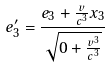<formula> <loc_0><loc_0><loc_500><loc_500>e _ { 3 } ^ { \prime } = \frac { e _ { 3 } + \frac { v } { c ^ { 3 } } x _ { 3 } } { \sqrt { 0 + \frac { v ^ { 3 } } { c ^ { 3 } } } }</formula> 